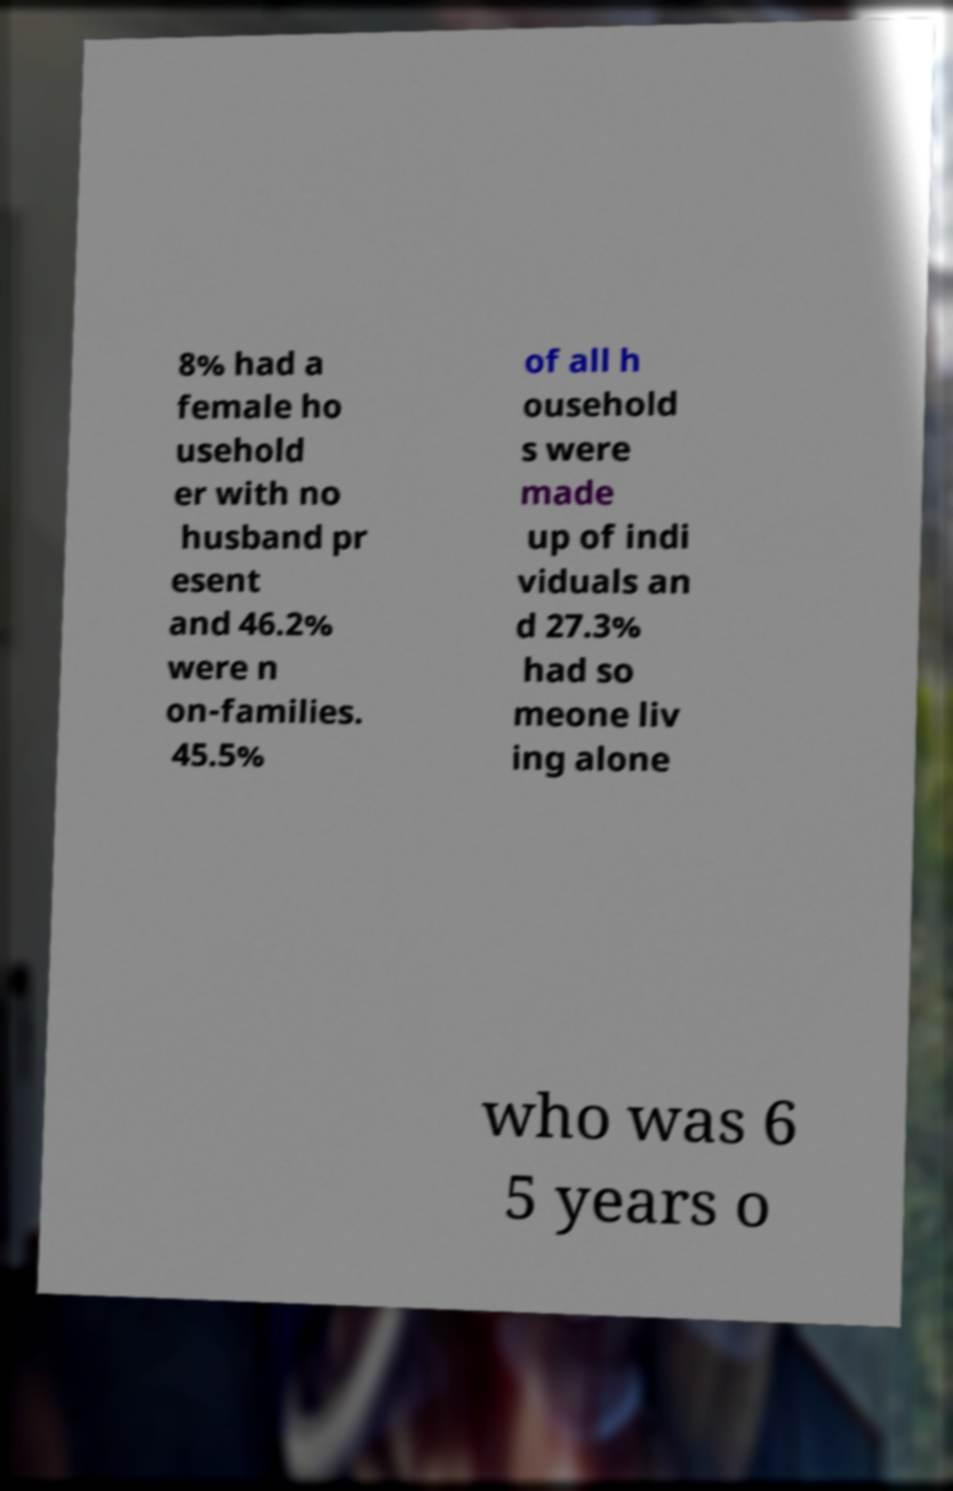Please read and relay the text visible in this image. What does it say? 8% had a female ho usehold er with no husband pr esent and 46.2% were n on-families. 45.5% of all h ousehold s were made up of indi viduals an d 27.3% had so meone liv ing alone who was 6 5 years o 